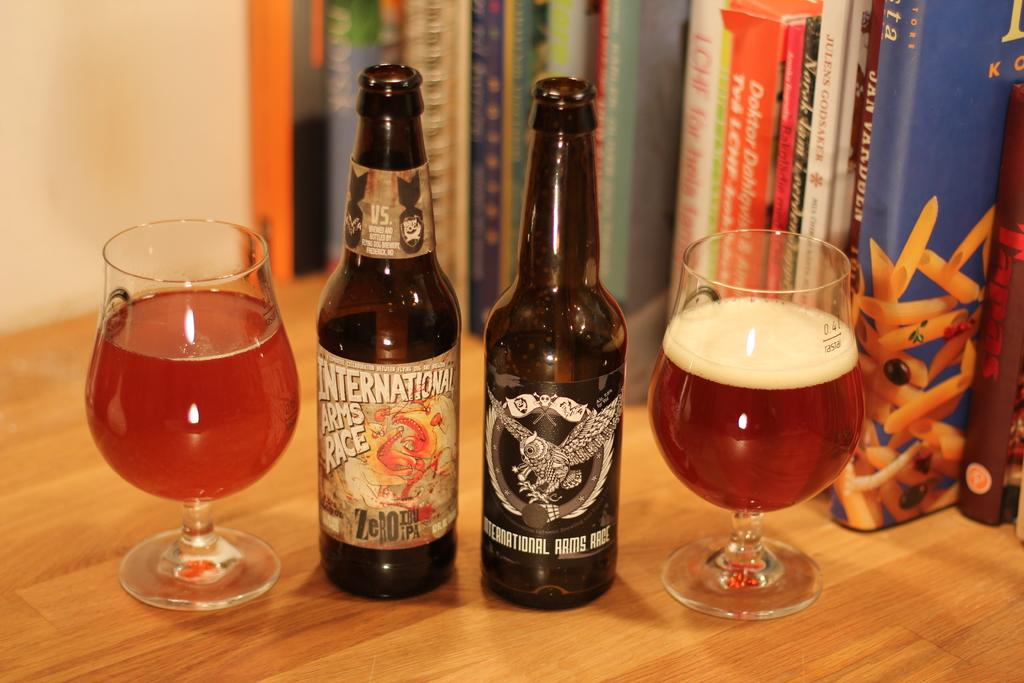<image>
Write a terse but informative summary of the picture. A bottle of International Arms Race Zero IBU IPA next to a half full glass and another bottle. 